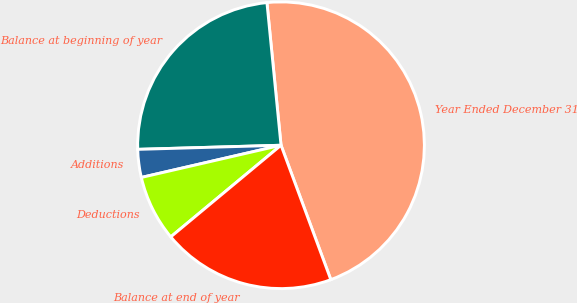Convert chart to OTSL. <chart><loc_0><loc_0><loc_500><loc_500><pie_chart><fcel>Year Ended December 31<fcel>Balance at beginning of year<fcel>Additions<fcel>Deductions<fcel>Balance at end of year<nl><fcel>45.92%<fcel>23.89%<fcel>3.15%<fcel>7.43%<fcel>19.61%<nl></chart> 